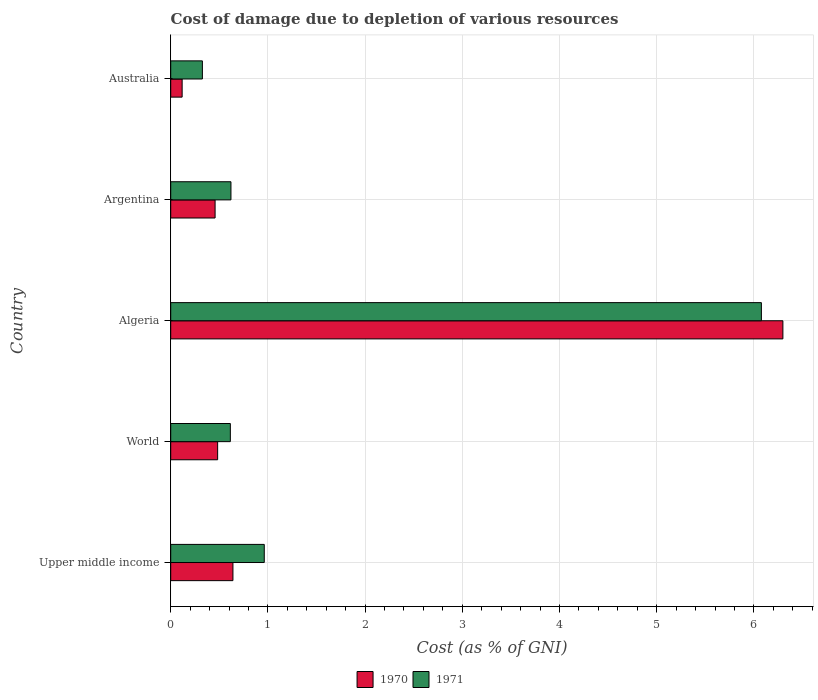How many different coloured bars are there?
Your answer should be very brief. 2. How many groups of bars are there?
Ensure brevity in your answer.  5. Are the number of bars per tick equal to the number of legend labels?
Provide a succinct answer. Yes. Are the number of bars on each tick of the Y-axis equal?
Provide a succinct answer. Yes. How many bars are there on the 1st tick from the top?
Offer a terse response. 2. How many bars are there on the 4th tick from the bottom?
Ensure brevity in your answer.  2. What is the label of the 5th group of bars from the top?
Your response must be concise. Upper middle income. In how many cases, is the number of bars for a given country not equal to the number of legend labels?
Make the answer very short. 0. What is the cost of damage caused due to the depletion of various resources in 1970 in World?
Your response must be concise. 0.48. Across all countries, what is the maximum cost of damage caused due to the depletion of various resources in 1971?
Provide a succinct answer. 6.08. Across all countries, what is the minimum cost of damage caused due to the depletion of various resources in 1970?
Your answer should be compact. 0.12. In which country was the cost of damage caused due to the depletion of various resources in 1970 maximum?
Ensure brevity in your answer.  Algeria. In which country was the cost of damage caused due to the depletion of various resources in 1971 minimum?
Your answer should be compact. Australia. What is the total cost of damage caused due to the depletion of various resources in 1970 in the graph?
Your response must be concise. 8. What is the difference between the cost of damage caused due to the depletion of various resources in 1971 in Upper middle income and that in World?
Provide a succinct answer. 0.35. What is the difference between the cost of damage caused due to the depletion of various resources in 1971 in Australia and the cost of damage caused due to the depletion of various resources in 1970 in Argentina?
Offer a very short reply. -0.13. What is the average cost of damage caused due to the depletion of various resources in 1971 per country?
Make the answer very short. 1.72. What is the difference between the cost of damage caused due to the depletion of various resources in 1971 and cost of damage caused due to the depletion of various resources in 1970 in Australia?
Keep it short and to the point. 0.21. In how many countries, is the cost of damage caused due to the depletion of various resources in 1971 greater than 1.6 %?
Ensure brevity in your answer.  1. What is the ratio of the cost of damage caused due to the depletion of various resources in 1971 in Argentina to that in Australia?
Offer a terse response. 1.9. Is the difference between the cost of damage caused due to the depletion of various resources in 1971 in Argentina and World greater than the difference between the cost of damage caused due to the depletion of various resources in 1970 in Argentina and World?
Offer a very short reply. Yes. What is the difference between the highest and the second highest cost of damage caused due to the depletion of various resources in 1970?
Provide a succinct answer. 5.66. What is the difference between the highest and the lowest cost of damage caused due to the depletion of various resources in 1970?
Your response must be concise. 6.18. In how many countries, is the cost of damage caused due to the depletion of various resources in 1970 greater than the average cost of damage caused due to the depletion of various resources in 1970 taken over all countries?
Provide a short and direct response. 1. What does the 1st bar from the top in World represents?
Your answer should be very brief. 1971. Are all the bars in the graph horizontal?
Keep it short and to the point. Yes. How many countries are there in the graph?
Keep it short and to the point. 5. Are the values on the major ticks of X-axis written in scientific E-notation?
Provide a succinct answer. No. Does the graph contain any zero values?
Offer a terse response. No. How many legend labels are there?
Provide a succinct answer. 2. How are the legend labels stacked?
Keep it short and to the point. Horizontal. What is the title of the graph?
Offer a very short reply. Cost of damage due to depletion of various resources. Does "1998" appear as one of the legend labels in the graph?
Keep it short and to the point. No. What is the label or title of the X-axis?
Provide a succinct answer. Cost (as % of GNI). What is the Cost (as % of GNI) of 1970 in Upper middle income?
Offer a very short reply. 0.64. What is the Cost (as % of GNI) of 1971 in Upper middle income?
Offer a terse response. 0.96. What is the Cost (as % of GNI) in 1970 in World?
Your answer should be very brief. 0.48. What is the Cost (as % of GNI) in 1971 in World?
Your answer should be very brief. 0.61. What is the Cost (as % of GNI) in 1970 in Algeria?
Keep it short and to the point. 6.3. What is the Cost (as % of GNI) in 1971 in Algeria?
Keep it short and to the point. 6.08. What is the Cost (as % of GNI) of 1970 in Argentina?
Provide a short and direct response. 0.46. What is the Cost (as % of GNI) in 1971 in Argentina?
Your answer should be very brief. 0.62. What is the Cost (as % of GNI) in 1970 in Australia?
Your answer should be compact. 0.12. What is the Cost (as % of GNI) in 1971 in Australia?
Ensure brevity in your answer.  0.33. Across all countries, what is the maximum Cost (as % of GNI) of 1970?
Ensure brevity in your answer.  6.3. Across all countries, what is the maximum Cost (as % of GNI) of 1971?
Provide a short and direct response. 6.08. Across all countries, what is the minimum Cost (as % of GNI) of 1970?
Provide a short and direct response. 0.12. Across all countries, what is the minimum Cost (as % of GNI) in 1971?
Offer a very short reply. 0.33. What is the total Cost (as % of GNI) of 1970 in the graph?
Your response must be concise. 8. What is the total Cost (as % of GNI) in 1971 in the graph?
Offer a terse response. 8.6. What is the difference between the Cost (as % of GNI) in 1970 in Upper middle income and that in World?
Give a very brief answer. 0.16. What is the difference between the Cost (as % of GNI) in 1971 in Upper middle income and that in World?
Ensure brevity in your answer.  0.35. What is the difference between the Cost (as % of GNI) of 1970 in Upper middle income and that in Algeria?
Provide a short and direct response. -5.66. What is the difference between the Cost (as % of GNI) of 1971 in Upper middle income and that in Algeria?
Give a very brief answer. -5.11. What is the difference between the Cost (as % of GNI) in 1970 in Upper middle income and that in Argentina?
Provide a short and direct response. 0.18. What is the difference between the Cost (as % of GNI) of 1971 in Upper middle income and that in Argentina?
Ensure brevity in your answer.  0.34. What is the difference between the Cost (as % of GNI) in 1970 in Upper middle income and that in Australia?
Provide a succinct answer. 0.52. What is the difference between the Cost (as % of GNI) in 1971 in Upper middle income and that in Australia?
Your answer should be compact. 0.64. What is the difference between the Cost (as % of GNI) of 1970 in World and that in Algeria?
Your answer should be compact. -5.82. What is the difference between the Cost (as % of GNI) of 1971 in World and that in Algeria?
Your response must be concise. -5.46. What is the difference between the Cost (as % of GNI) of 1970 in World and that in Argentina?
Make the answer very short. 0.03. What is the difference between the Cost (as % of GNI) in 1971 in World and that in Argentina?
Make the answer very short. -0.01. What is the difference between the Cost (as % of GNI) in 1970 in World and that in Australia?
Provide a short and direct response. 0.37. What is the difference between the Cost (as % of GNI) in 1971 in World and that in Australia?
Keep it short and to the point. 0.29. What is the difference between the Cost (as % of GNI) in 1970 in Algeria and that in Argentina?
Provide a succinct answer. 5.84. What is the difference between the Cost (as % of GNI) in 1971 in Algeria and that in Argentina?
Your answer should be compact. 5.46. What is the difference between the Cost (as % of GNI) in 1970 in Algeria and that in Australia?
Your answer should be very brief. 6.18. What is the difference between the Cost (as % of GNI) of 1971 in Algeria and that in Australia?
Make the answer very short. 5.75. What is the difference between the Cost (as % of GNI) of 1970 in Argentina and that in Australia?
Keep it short and to the point. 0.34. What is the difference between the Cost (as % of GNI) in 1971 in Argentina and that in Australia?
Provide a succinct answer. 0.29. What is the difference between the Cost (as % of GNI) in 1970 in Upper middle income and the Cost (as % of GNI) in 1971 in World?
Make the answer very short. 0.03. What is the difference between the Cost (as % of GNI) in 1970 in Upper middle income and the Cost (as % of GNI) in 1971 in Algeria?
Offer a very short reply. -5.44. What is the difference between the Cost (as % of GNI) in 1970 in Upper middle income and the Cost (as % of GNI) in 1971 in Argentina?
Offer a very short reply. 0.02. What is the difference between the Cost (as % of GNI) in 1970 in Upper middle income and the Cost (as % of GNI) in 1971 in Australia?
Keep it short and to the point. 0.31. What is the difference between the Cost (as % of GNI) in 1970 in World and the Cost (as % of GNI) in 1971 in Algeria?
Provide a short and direct response. -5.59. What is the difference between the Cost (as % of GNI) in 1970 in World and the Cost (as % of GNI) in 1971 in Argentina?
Provide a short and direct response. -0.14. What is the difference between the Cost (as % of GNI) of 1970 in World and the Cost (as % of GNI) of 1971 in Australia?
Ensure brevity in your answer.  0.16. What is the difference between the Cost (as % of GNI) of 1970 in Algeria and the Cost (as % of GNI) of 1971 in Argentina?
Provide a succinct answer. 5.68. What is the difference between the Cost (as % of GNI) in 1970 in Algeria and the Cost (as % of GNI) in 1971 in Australia?
Provide a succinct answer. 5.97. What is the difference between the Cost (as % of GNI) of 1970 in Argentina and the Cost (as % of GNI) of 1971 in Australia?
Keep it short and to the point. 0.13. What is the average Cost (as % of GNI) in 1970 per country?
Your answer should be compact. 1.6. What is the average Cost (as % of GNI) in 1971 per country?
Offer a very short reply. 1.72. What is the difference between the Cost (as % of GNI) in 1970 and Cost (as % of GNI) in 1971 in Upper middle income?
Offer a very short reply. -0.32. What is the difference between the Cost (as % of GNI) of 1970 and Cost (as % of GNI) of 1971 in World?
Make the answer very short. -0.13. What is the difference between the Cost (as % of GNI) of 1970 and Cost (as % of GNI) of 1971 in Algeria?
Ensure brevity in your answer.  0.22. What is the difference between the Cost (as % of GNI) of 1970 and Cost (as % of GNI) of 1971 in Argentina?
Provide a succinct answer. -0.16. What is the difference between the Cost (as % of GNI) in 1970 and Cost (as % of GNI) in 1971 in Australia?
Your answer should be compact. -0.21. What is the ratio of the Cost (as % of GNI) of 1970 in Upper middle income to that in World?
Make the answer very short. 1.33. What is the ratio of the Cost (as % of GNI) of 1971 in Upper middle income to that in World?
Your response must be concise. 1.57. What is the ratio of the Cost (as % of GNI) of 1970 in Upper middle income to that in Algeria?
Keep it short and to the point. 0.1. What is the ratio of the Cost (as % of GNI) of 1971 in Upper middle income to that in Algeria?
Offer a very short reply. 0.16. What is the ratio of the Cost (as % of GNI) of 1970 in Upper middle income to that in Argentina?
Keep it short and to the point. 1.4. What is the ratio of the Cost (as % of GNI) in 1971 in Upper middle income to that in Argentina?
Keep it short and to the point. 1.55. What is the ratio of the Cost (as % of GNI) in 1970 in Upper middle income to that in Australia?
Make the answer very short. 5.45. What is the ratio of the Cost (as % of GNI) in 1971 in Upper middle income to that in Australia?
Give a very brief answer. 2.95. What is the ratio of the Cost (as % of GNI) in 1970 in World to that in Algeria?
Provide a short and direct response. 0.08. What is the ratio of the Cost (as % of GNI) of 1971 in World to that in Algeria?
Provide a short and direct response. 0.1. What is the ratio of the Cost (as % of GNI) in 1970 in World to that in Argentina?
Your answer should be compact. 1.06. What is the ratio of the Cost (as % of GNI) of 1970 in World to that in Australia?
Offer a terse response. 4.11. What is the ratio of the Cost (as % of GNI) of 1971 in World to that in Australia?
Provide a short and direct response. 1.88. What is the ratio of the Cost (as % of GNI) in 1970 in Algeria to that in Argentina?
Ensure brevity in your answer.  13.8. What is the ratio of the Cost (as % of GNI) in 1971 in Algeria to that in Argentina?
Your answer should be very brief. 9.81. What is the ratio of the Cost (as % of GNI) of 1970 in Algeria to that in Australia?
Offer a very short reply. 53.61. What is the ratio of the Cost (as % of GNI) in 1971 in Algeria to that in Australia?
Ensure brevity in your answer.  18.65. What is the ratio of the Cost (as % of GNI) in 1970 in Argentina to that in Australia?
Your answer should be very brief. 3.89. What is the ratio of the Cost (as % of GNI) of 1971 in Argentina to that in Australia?
Ensure brevity in your answer.  1.9. What is the difference between the highest and the second highest Cost (as % of GNI) of 1970?
Ensure brevity in your answer.  5.66. What is the difference between the highest and the second highest Cost (as % of GNI) of 1971?
Provide a succinct answer. 5.11. What is the difference between the highest and the lowest Cost (as % of GNI) of 1970?
Provide a short and direct response. 6.18. What is the difference between the highest and the lowest Cost (as % of GNI) in 1971?
Offer a very short reply. 5.75. 